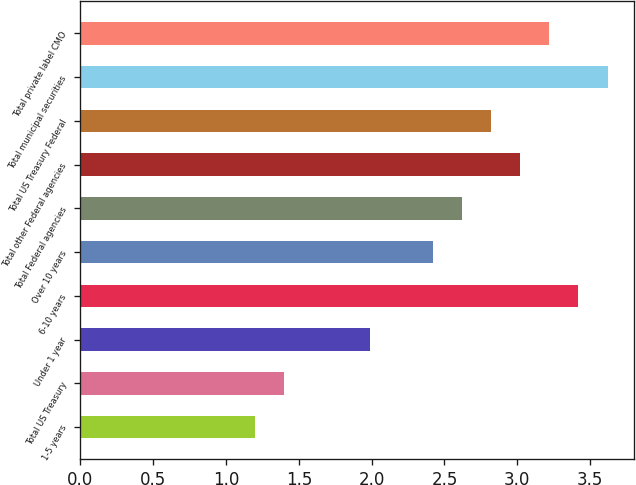Convert chart. <chart><loc_0><loc_0><loc_500><loc_500><bar_chart><fcel>1-5 years<fcel>Total US Treasury<fcel>Under 1 year<fcel>6-10 years<fcel>Over 10 years<fcel>Total Federal agencies<fcel>Total other Federal agencies<fcel>Total US Treasury Federal<fcel>Total municipal securities<fcel>Total private label CMO<nl><fcel>1.2<fcel>1.4<fcel>1.99<fcel>3.42<fcel>2.42<fcel>2.62<fcel>3.02<fcel>2.82<fcel>3.62<fcel>3.22<nl></chart> 